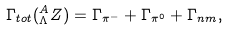Convert formula to latex. <formula><loc_0><loc_0><loc_500><loc_500>\Gamma _ { t o t } ( ^ { A } _ { \Lambda } Z ) = \Gamma _ { \pi ^ { - } } + \Gamma _ { \pi ^ { 0 } } + \Gamma _ { n m } ,</formula> 